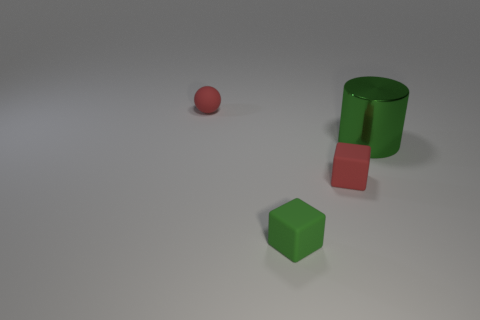Does the arrangement of these objects suggest any particular pattern or design? The objects appear to be randomly placed without a specific pattern. The different geometric shapes and varying distances between them suggest no intentional design. Could you imagine a context where these objects might be used together? Imaginatively, these geometrical figures could be part of an educational set, intended to help students learn about shapes, volumes, and colors. 